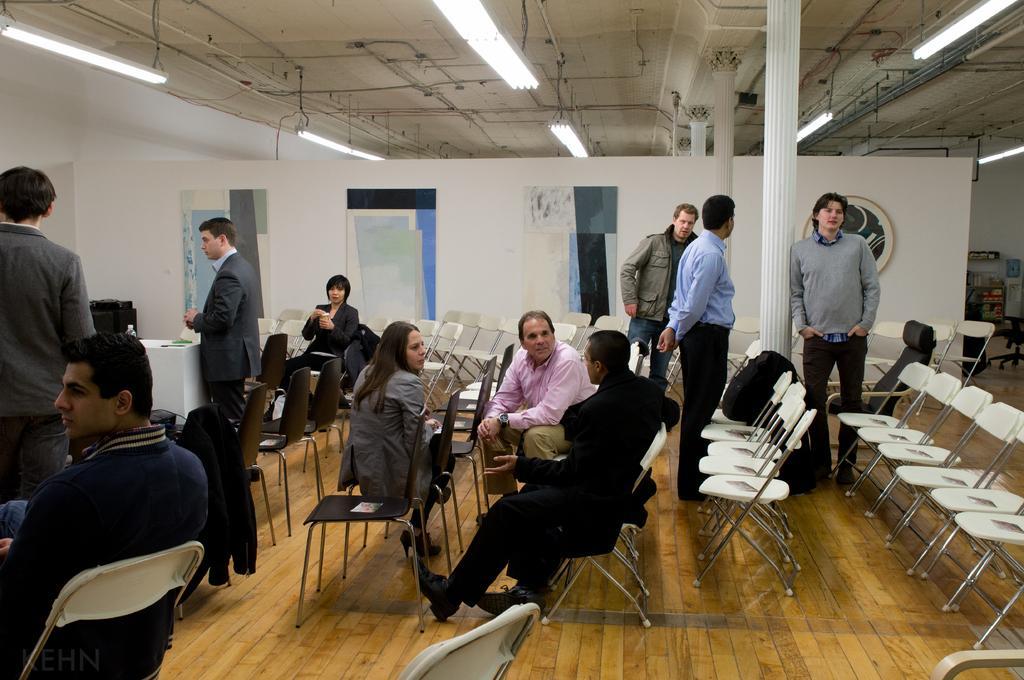Can you describe this image briefly? In this picture I can see few persons are sitting on the chairs. On the right side few persons are standing, at the top there are lights. 